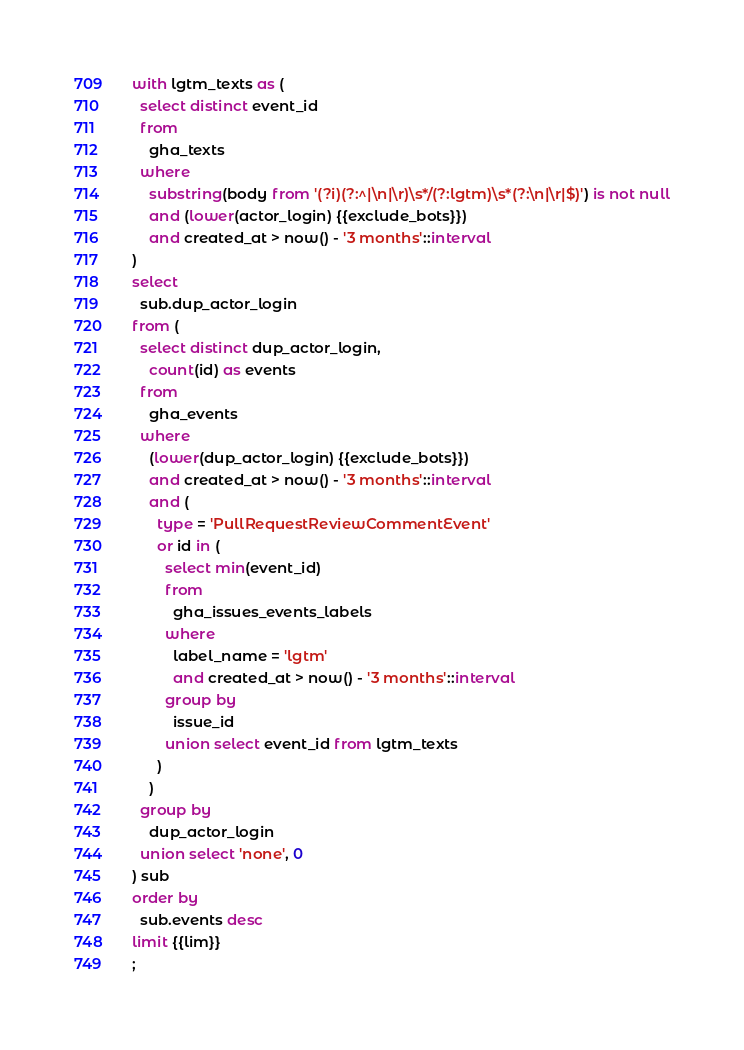<code> <loc_0><loc_0><loc_500><loc_500><_SQL_>with lgtm_texts as (
  select distinct event_id
  from
    gha_texts
  where
    substring(body from '(?i)(?:^|\n|\r)\s*/(?:lgtm)\s*(?:\n|\r|$)') is not null
    and (lower(actor_login) {{exclude_bots}})
    and created_at > now() - '3 months'::interval
)
select
  sub.dup_actor_login
from (
  select distinct dup_actor_login,
    count(id) as events
  from
    gha_events
  where
    (lower(dup_actor_login) {{exclude_bots}})
    and created_at > now() - '3 months'::interval
    and (
      type = 'PullRequestReviewCommentEvent'
      or id in (
        select min(event_id)
        from
          gha_issues_events_labels
        where
          label_name = 'lgtm'
          and created_at > now() - '3 months'::interval
        group by
          issue_id
        union select event_id from lgtm_texts
      )
    )
  group by
    dup_actor_login
  union select 'none', 0
) sub
order by
  sub.events desc
limit {{lim}}
;
</code> 